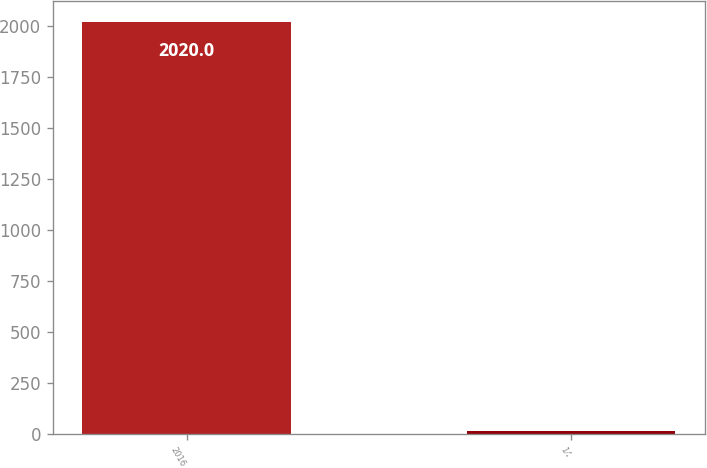<chart> <loc_0><loc_0><loc_500><loc_500><bar_chart><fcel>2016<fcel>14<nl><fcel>2020<fcel>13<nl></chart> 